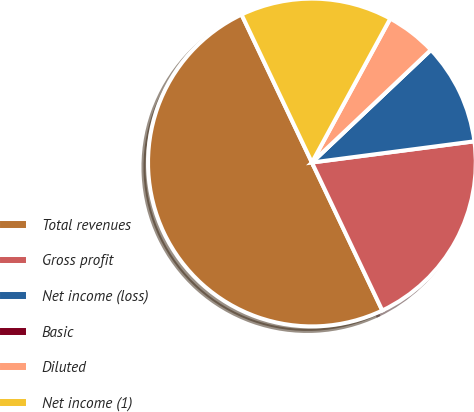Convert chart to OTSL. <chart><loc_0><loc_0><loc_500><loc_500><pie_chart><fcel>Total revenues<fcel>Gross profit<fcel>Net income (loss)<fcel>Basic<fcel>Diluted<fcel>Net income (1)<nl><fcel>50.0%<fcel>20.0%<fcel>10.0%<fcel>0.0%<fcel>5.0%<fcel>15.0%<nl></chart> 